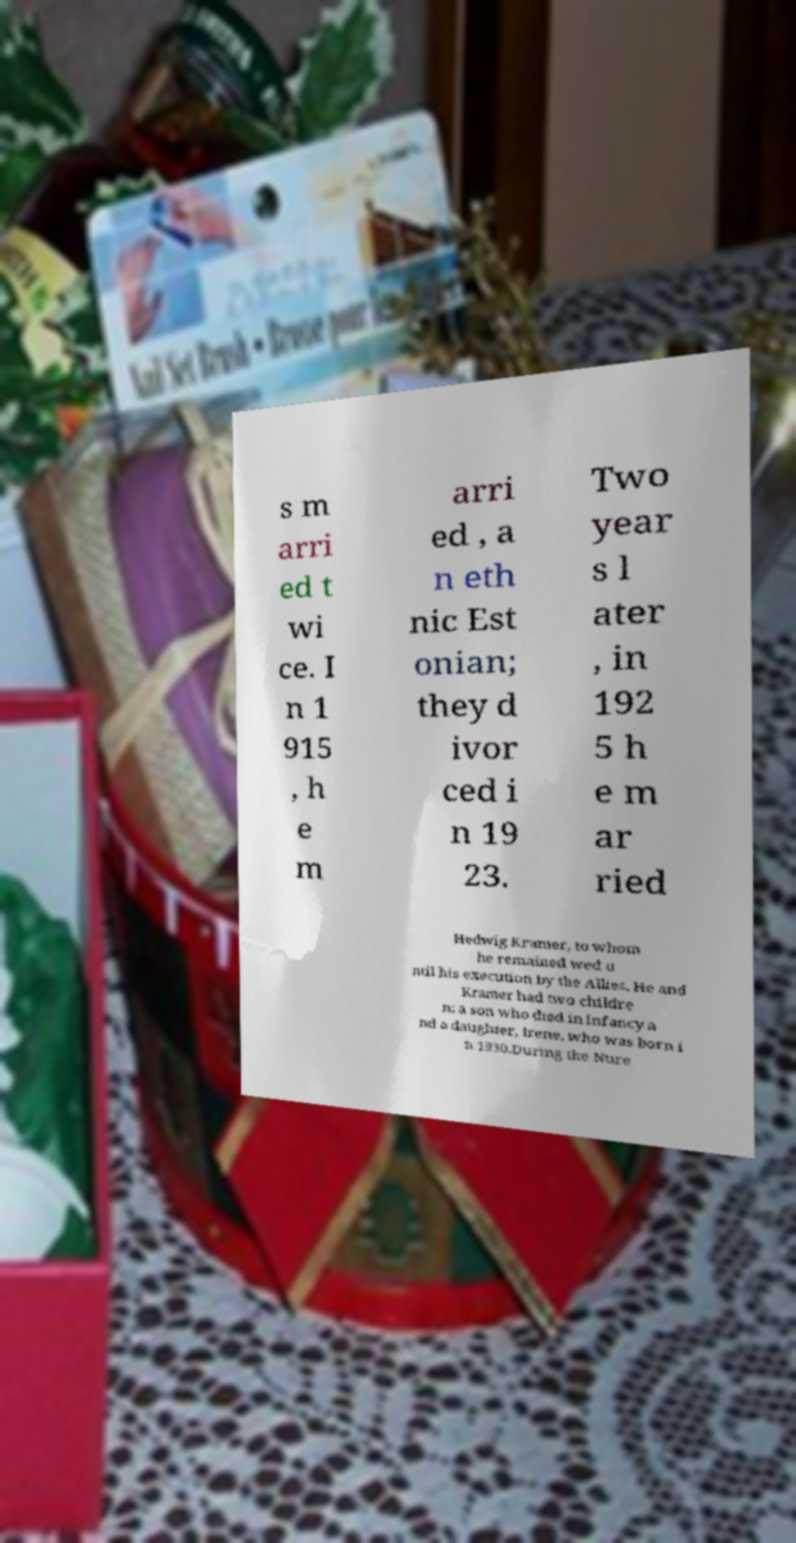Can you read and provide the text displayed in the image?This photo seems to have some interesting text. Can you extract and type it out for me? s m arri ed t wi ce. I n 1 915 , h e m arri ed , a n eth nic Est onian; they d ivor ced i n 19 23. Two year s l ater , in 192 5 h e m ar ried Hedwig Kramer, to whom he remained wed u ntil his execution by the Allies. He and Kramer had two childre n: a son who died in infancy a nd a daughter, Irene, who was born i n 1930.During the Nure 